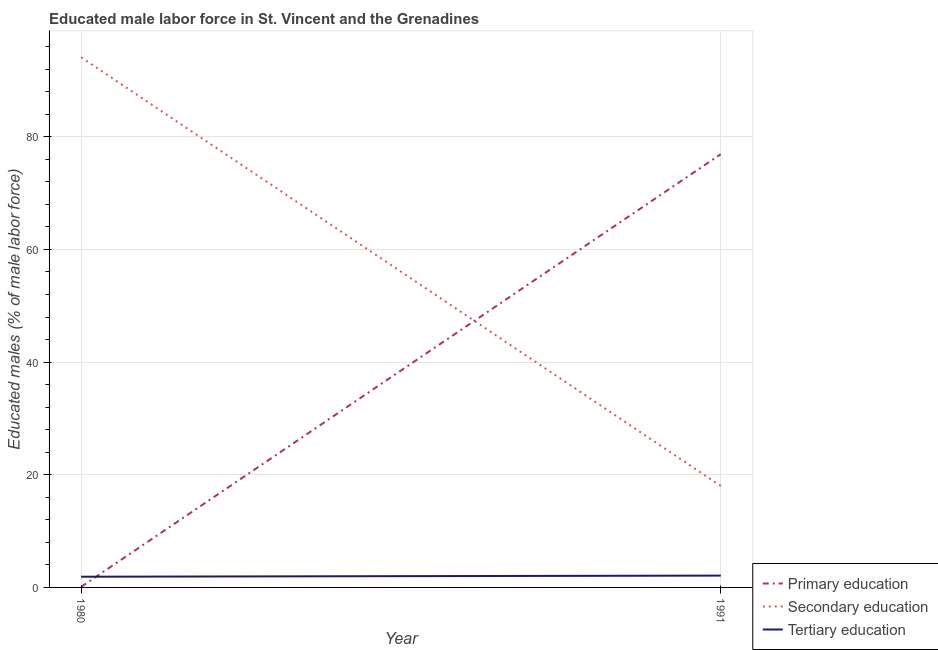Does the line corresponding to percentage of male labor force who received primary education intersect with the line corresponding to percentage of male labor force who received tertiary education?
Provide a succinct answer. Yes. What is the percentage of male labor force who received tertiary education in 1991?
Your response must be concise. 2.1. Across all years, what is the maximum percentage of male labor force who received tertiary education?
Provide a short and direct response. 2.1. In which year was the percentage of male labor force who received secondary education maximum?
Provide a succinct answer. 1980. In which year was the percentage of male labor force who received secondary education minimum?
Your answer should be compact. 1991. What is the total percentage of male labor force who received tertiary education in the graph?
Ensure brevity in your answer.  4. What is the difference between the percentage of male labor force who received secondary education in 1980 and that in 1991?
Keep it short and to the point. 76.1. What is the difference between the percentage of male labor force who received tertiary education in 1980 and the percentage of male labor force who received primary education in 1991?
Your answer should be very brief. -75. What is the average percentage of male labor force who received secondary education per year?
Provide a short and direct response. 56.05. In the year 1991, what is the difference between the percentage of male labor force who received secondary education and percentage of male labor force who received primary education?
Your response must be concise. -58.9. In how many years, is the percentage of male labor force who received secondary education greater than 52 %?
Offer a very short reply. 1. What is the ratio of the percentage of male labor force who received tertiary education in 1980 to that in 1991?
Offer a terse response. 0.9. In how many years, is the percentage of male labor force who received secondary education greater than the average percentage of male labor force who received secondary education taken over all years?
Give a very brief answer. 1. Is the percentage of male labor force who received tertiary education strictly less than the percentage of male labor force who received primary education over the years?
Offer a terse response. No. How many lines are there?
Your response must be concise. 3. How many years are there in the graph?
Your response must be concise. 2. What is the difference between two consecutive major ticks on the Y-axis?
Make the answer very short. 20. Are the values on the major ticks of Y-axis written in scientific E-notation?
Give a very brief answer. No. Does the graph contain any zero values?
Provide a succinct answer. No. Does the graph contain grids?
Ensure brevity in your answer.  Yes. How many legend labels are there?
Provide a short and direct response. 3. How are the legend labels stacked?
Offer a very short reply. Vertical. What is the title of the graph?
Give a very brief answer. Educated male labor force in St. Vincent and the Grenadines. What is the label or title of the Y-axis?
Offer a very short reply. Educated males (% of male labor force). What is the Educated males (% of male labor force) in Primary education in 1980?
Your answer should be very brief. 0.1. What is the Educated males (% of male labor force) of Secondary education in 1980?
Your response must be concise. 94.1. What is the Educated males (% of male labor force) in Tertiary education in 1980?
Your answer should be compact. 1.9. What is the Educated males (% of male labor force) in Primary education in 1991?
Offer a very short reply. 76.9. What is the Educated males (% of male labor force) in Secondary education in 1991?
Provide a succinct answer. 18. What is the Educated males (% of male labor force) of Tertiary education in 1991?
Provide a succinct answer. 2.1. Across all years, what is the maximum Educated males (% of male labor force) of Primary education?
Give a very brief answer. 76.9. Across all years, what is the maximum Educated males (% of male labor force) of Secondary education?
Offer a very short reply. 94.1. Across all years, what is the maximum Educated males (% of male labor force) in Tertiary education?
Give a very brief answer. 2.1. Across all years, what is the minimum Educated males (% of male labor force) of Primary education?
Your answer should be compact. 0.1. Across all years, what is the minimum Educated males (% of male labor force) of Tertiary education?
Make the answer very short. 1.9. What is the total Educated males (% of male labor force) in Secondary education in the graph?
Provide a short and direct response. 112.1. What is the total Educated males (% of male labor force) of Tertiary education in the graph?
Ensure brevity in your answer.  4. What is the difference between the Educated males (% of male labor force) in Primary education in 1980 and that in 1991?
Offer a terse response. -76.8. What is the difference between the Educated males (% of male labor force) of Secondary education in 1980 and that in 1991?
Provide a succinct answer. 76.1. What is the difference between the Educated males (% of male labor force) in Primary education in 1980 and the Educated males (% of male labor force) in Secondary education in 1991?
Your answer should be compact. -17.9. What is the difference between the Educated males (% of male labor force) of Secondary education in 1980 and the Educated males (% of male labor force) of Tertiary education in 1991?
Make the answer very short. 92. What is the average Educated males (% of male labor force) in Primary education per year?
Your answer should be compact. 38.5. What is the average Educated males (% of male labor force) of Secondary education per year?
Your answer should be very brief. 56.05. In the year 1980, what is the difference between the Educated males (% of male labor force) of Primary education and Educated males (% of male labor force) of Secondary education?
Ensure brevity in your answer.  -94. In the year 1980, what is the difference between the Educated males (% of male labor force) in Primary education and Educated males (% of male labor force) in Tertiary education?
Ensure brevity in your answer.  -1.8. In the year 1980, what is the difference between the Educated males (% of male labor force) of Secondary education and Educated males (% of male labor force) of Tertiary education?
Your answer should be compact. 92.2. In the year 1991, what is the difference between the Educated males (% of male labor force) of Primary education and Educated males (% of male labor force) of Secondary education?
Your answer should be very brief. 58.9. In the year 1991, what is the difference between the Educated males (% of male labor force) in Primary education and Educated males (% of male labor force) in Tertiary education?
Give a very brief answer. 74.8. In the year 1991, what is the difference between the Educated males (% of male labor force) in Secondary education and Educated males (% of male labor force) in Tertiary education?
Offer a terse response. 15.9. What is the ratio of the Educated males (% of male labor force) of Primary education in 1980 to that in 1991?
Give a very brief answer. 0. What is the ratio of the Educated males (% of male labor force) of Secondary education in 1980 to that in 1991?
Provide a succinct answer. 5.23. What is the ratio of the Educated males (% of male labor force) in Tertiary education in 1980 to that in 1991?
Provide a short and direct response. 0.9. What is the difference between the highest and the second highest Educated males (% of male labor force) in Primary education?
Offer a very short reply. 76.8. What is the difference between the highest and the second highest Educated males (% of male labor force) of Secondary education?
Offer a very short reply. 76.1. What is the difference between the highest and the lowest Educated males (% of male labor force) of Primary education?
Your answer should be compact. 76.8. What is the difference between the highest and the lowest Educated males (% of male labor force) in Secondary education?
Offer a very short reply. 76.1. 